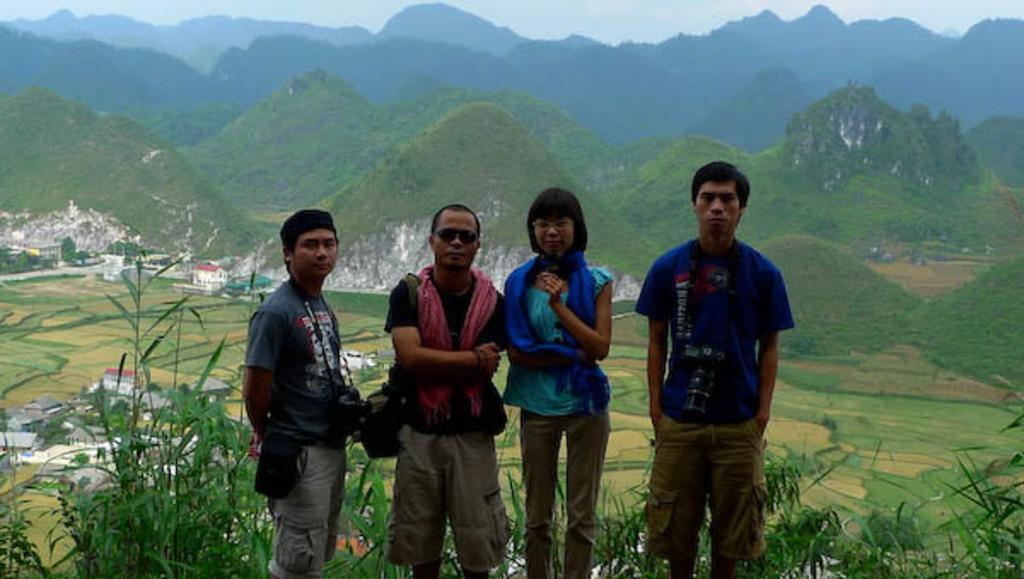Please provide a concise description of this image. In this image I can see there are four persons visible standing on grass and I can see houses and hills and the sky visible in the background and in the foreground I can see plants and I can see three persons holding cameras on their necks. 